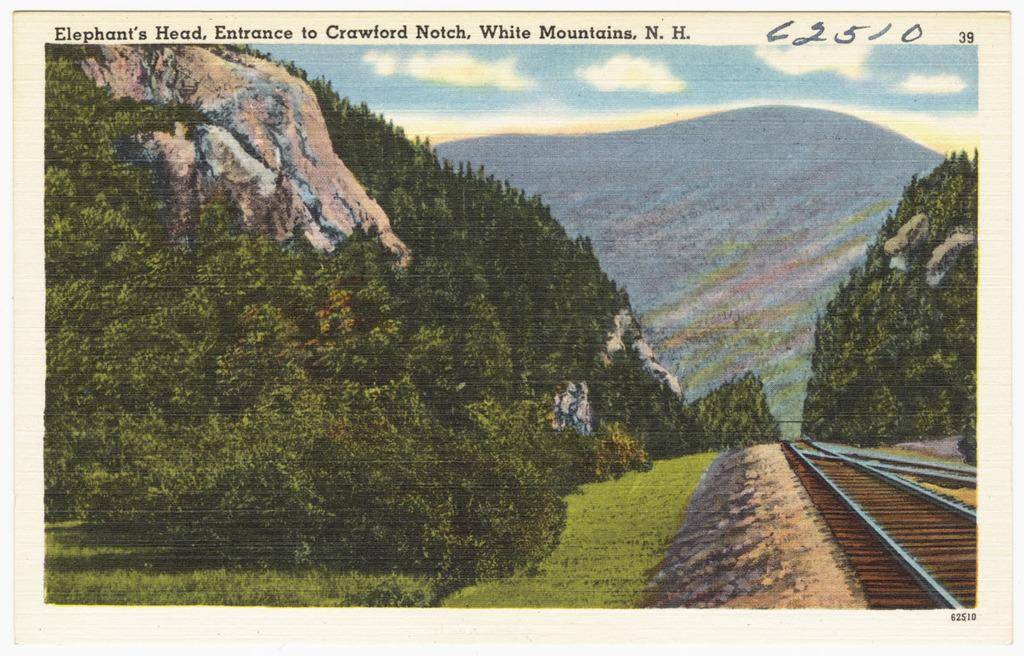What type of vegetation can be seen in the image? There are trees and grass in the image. What man-made structure is present in the image? There are railway tracks in the image. What can be seen in the sky in the image? There are clouds in the image, and the sky is visible. Is there any text present in the image? Yes, there is text written in the image. What type of zephyr can be seen blowing through the trees in the image? There is no zephyr present in the image; it is a meteorological term for a gentle breeze, and there is no indication of wind in the image. How does the hope depicted in the image rest on the railway tracks? There is no hope or resting depicted in the image; it only contains trees, grass, railway tracks, clouds, the sky, and text. 